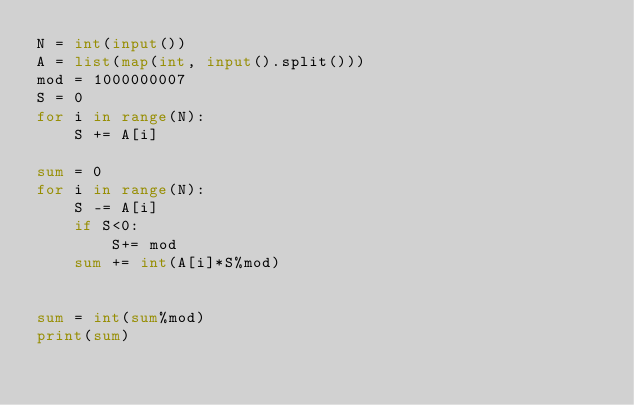Convert code to text. <code><loc_0><loc_0><loc_500><loc_500><_Python_>N = int(input())
A = list(map(int, input().split()))
mod = 1000000007
S = 0
for i in range(N):
    S += A[i]

sum = 0
for i in range(N):
    S -= A[i]
    if S<0:
        S+= mod
    sum += int(A[i]*S%mod)
    

sum = int(sum%mod)    
print(sum)</code> 